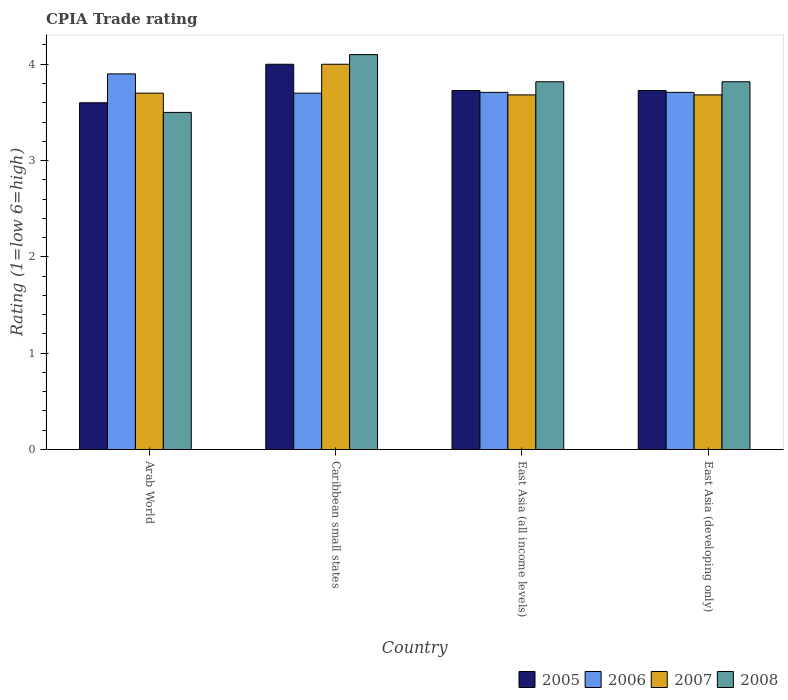How many different coloured bars are there?
Your response must be concise. 4. How many groups of bars are there?
Provide a succinct answer. 4. What is the label of the 1st group of bars from the left?
Keep it short and to the point. Arab World. In how many cases, is the number of bars for a given country not equal to the number of legend labels?
Offer a very short reply. 0. What is the CPIA rating in 2007 in Caribbean small states?
Ensure brevity in your answer.  4. Across all countries, what is the maximum CPIA rating in 2006?
Ensure brevity in your answer.  3.9. Across all countries, what is the minimum CPIA rating in 2006?
Offer a terse response. 3.7. In which country was the CPIA rating in 2007 maximum?
Your answer should be very brief. Caribbean small states. In which country was the CPIA rating in 2005 minimum?
Your answer should be compact. Arab World. What is the total CPIA rating in 2006 in the graph?
Your answer should be very brief. 15.02. What is the difference between the CPIA rating in 2007 in Caribbean small states and that in East Asia (developing only)?
Your answer should be compact. 0.32. What is the difference between the CPIA rating in 2008 in East Asia (all income levels) and the CPIA rating in 2007 in East Asia (developing only)?
Your answer should be very brief. 0.14. What is the average CPIA rating in 2005 per country?
Make the answer very short. 3.76. What is the difference between the CPIA rating of/in 2007 and CPIA rating of/in 2005 in East Asia (developing only)?
Your answer should be compact. -0.05. What is the ratio of the CPIA rating in 2008 in Arab World to that in Caribbean small states?
Provide a succinct answer. 0.85. Is the difference between the CPIA rating in 2007 in East Asia (all income levels) and East Asia (developing only) greater than the difference between the CPIA rating in 2005 in East Asia (all income levels) and East Asia (developing only)?
Make the answer very short. No. What is the difference between the highest and the second highest CPIA rating in 2007?
Keep it short and to the point. -0.02. What is the difference between the highest and the lowest CPIA rating in 2007?
Offer a terse response. 0.32. Is the sum of the CPIA rating in 2005 in East Asia (all income levels) and East Asia (developing only) greater than the maximum CPIA rating in 2006 across all countries?
Offer a terse response. Yes. Is it the case that in every country, the sum of the CPIA rating in 2007 and CPIA rating in 2008 is greater than the sum of CPIA rating in 2005 and CPIA rating in 2006?
Provide a succinct answer. No. What does the 2nd bar from the left in East Asia (all income levels) represents?
Ensure brevity in your answer.  2006. Is it the case that in every country, the sum of the CPIA rating in 2005 and CPIA rating in 2007 is greater than the CPIA rating in 2006?
Offer a very short reply. Yes. How many bars are there?
Provide a short and direct response. 16. How many countries are there in the graph?
Ensure brevity in your answer.  4. What is the difference between two consecutive major ticks on the Y-axis?
Offer a terse response. 1. Are the values on the major ticks of Y-axis written in scientific E-notation?
Your response must be concise. No. How many legend labels are there?
Keep it short and to the point. 4. How are the legend labels stacked?
Provide a succinct answer. Horizontal. What is the title of the graph?
Offer a very short reply. CPIA Trade rating. What is the label or title of the X-axis?
Your answer should be very brief. Country. What is the label or title of the Y-axis?
Ensure brevity in your answer.  Rating (1=low 6=high). What is the Rating (1=low 6=high) of 2007 in Arab World?
Offer a very short reply. 3.7. What is the Rating (1=low 6=high) in 2005 in East Asia (all income levels)?
Your answer should be very brief. 3.73. What is the Rating (1=low 6=high) in 2006 in East Asia (all income levels)?
Offer a very short reply. 3.71. What is the Rating (1=low 6=high) in 2007 in East Asia (all income levels)?
Your answer should be compact. 3.68. What is the Rating (1=low 6=high) in 2008 in East Asia (all income levels)?
Keep it short and to the point. 3.82. What is the Rating (1=low 6=high) of 2005 in East Asia (developing only)?
Provide a short and direct response. 3.73. What is the Rating (1=low 6=high) in 2006 in East Asia (developing only)?
Keep it short and to the point. 3.71. What is the Rating (1=low 6=high) in 2007 in East Asia (developing only)?
Offer a terse response. 3.68. What is the Rating (1=low 6=high) in 2008 in East Asia (developing only)?
Offer a very short reply. 3.82. Across all countries, what is the maximum Rating (1=low 6=high) of 2005?
Keep it short and to the point. 4. Across all countries, what is the minimum Rating (1=low 6=high) in 2007?
Offer a very short reply. 3.68. Across all countries, what is the minimum Rating (1=low 6=high) of 2008?
Keep it short and to the point. 3.5. What is the total Rating (1=low 6=high) in 2005 in the graph?
Your answer should be very brief. 15.05. What is the total Rating (1=low 6=high) of 2006 in the graph?
Your response must be concise. 15.02. What is the total Rating (1=low 6=high) in 2007 in the graph?
Ensure brevity in your answer.  15.06. What is the total Rating (1=low 6=high) of 2008 in the graph?
Ensure brevity in your answer.  15.24. What is the difference between the Rating (1=low 6=high) in 2008 in Arab World and that in Caribbean small states?
Your response must be concise. -0.6. What is the difference between the Rating (1=low 6=high) in 2005 in Arab World and that in East Asia (all income levels)?
Your answer should be compact. -0.13. What is the difference between the Rating (1=low 6=high) in 2006 in Arab World and that in East Asia (all income levels)?
Provide a succinct answer. 0.19. What is the difference between the Rating (1=low 6=high) in 2007 in Arab World and that in East Asia (all income levels)?
Ensure brevity in your answer.  0.02. What is the difference between the Rating (1=low 6=high) in 2008 in Arab World and that in East Asia (all income levels)?
Give a very brief answer. -0.32. What is the difference between the Rating (1=low 6=high) of 2005 in Arab World and that in East Asia (developing only)?
Provide a succinct answer. -0.13. What is the difference between the Rating (1=low 6=high) of 2006 in Arab World and that in East Asia (developing only)?
Your answer should be very brief. 0.19. What is the difference between the Rating (1=low 6=high) of 2007 in Arab World and that in East Asia (developing only)?
Your response must be concise. 0.02. What is the difference between the Rating (1=low 6=high) in 2008 in Arab World and that in East Asia (developing only)?
Offer a terse response. -0.32. What is the difference between the Rating (1=low 6=high) of 2005 in Caribbean small states and that in East Asia (all income levels)?
Your response must be concise. 0.27. What is the difference between the Rating (1=low 6=high) in 2006 in Caribbean small states and that in East Asia (all income levels)?
Your answer should be very brief. -0.01. What is the difference between the Rating (1=low 6=high) in 2007 in Caribbean small states and that in East Asia (all income levels)?
Offer a terse response. 0.32. What is the difference between the Rating (1=low 6=high) in 2008 in Caribbean small states and that in East Asia (all income levels)?
Give a very brief answer. 0.28. What is the difference between the Rating (1=low 6=high) in 2005 in Caribbean small states and that in East Asia (developing only)?
Offer a terse response. 0.27. What is the difference between the Rating (1=low 6=high) of 2006 in Caribbean small states and that in East Asia (developing only)?
Keep it short and to the point. -0.01. What is the difference between the Rating (1=low 6=high) in 2007 in Caribbean small states and that in East Asia (developing only)?
Your answer should be very brief. 0.32. What is the difference between the Rating (1=low 6=high) of 2008 in Caribbean small states and that in East Asia (developing only)?
Offer a terse response. 0.28. What is the difference between the Rating (1=low 6=high) in 2005 in East Asia (all income levels) and that in East Asia (developing only)?
Give a very brief answer. 0. What is the difference between the Rating (1=low 6=high) of 2006 in East Asia (all income levels) and that in East Asia (developing only)?
Make the answer very short. 0. What is the difference between the Rating (1=low 6=high) of 2005 in Arab World and the Rating (1=low 6=high) of 2007 in Caribbean small states?
Keep it short and to the point. -0.4. What is the difference between the Rating (1=low 6=high) in 2005 in Arab World and the Rating (1=low 6=high) in 2008 in Caribbean small states?
Make the answer very short. -0.5. What is the difference between the Rating (1=low 6=high) of 2006 in Arab World and the Rating (1=low 6=high) of 2007 in Caribbean small states?
Provide a succinct answer. -0.1. What is the difference between the Rating (1=low 6=high) of 2006 in Arab World and the Rating (1=low 6=high) of 2008 in Caribbean small states?
Give a very brief answer. -0.2. What is the difference between the Rating (1=low 6=high) of 2005 in Arab World and the Rating (1=low 6=high) of 2006 in East Asia (all income levels)?
Keep it short and to the point. -0.11. What is the difference between the Rating (1=low 6=high) in 2005 in Arab World and the Rating (1=low 6=high) in 2007 in East Asia (all income levels)?
Provide a short and direct response. -0.08. What is the difference between the Rating (1=low 6=high) in 2005 in Arab World and the Rating (1=low 6=high) in 2008 in East Asia (all income levels)?
Ensure brevity in your answer.  -0.22. What is the difference between the Rating (1=low 6=high) in 2006 in Arab World and the Rating (1=low 6=high) in 2007 in East Asia (all income levels)?
Give a very brief answer. 0.22. What is the difference between the Rating (1=low 6=high) of 2006 in Arab World and the Rating (1=low 6=high) of 2008 in East Asia (all income levels)?
Provide a short and direct response. 0.08. What is the difference between the Rating (1=low 6=high) of 2007 in Arab World and the Rating (1=low 6=high) of 2008 in East Asia (all income levels)?
Ensure brevity in your answer.  -0.12. What is the difference between the Rating (1=low 6=high) in 2005 in Arab World and the Rating (1=low 6=high) in 2006 in East Asia (developing only)?
Your response must be concise. -0.11. What is the difference between the Rating (1=low 6=high) of 2005 in Arab World and the Rating (1=low 6=high) of 2007 in East Asia (developing only)?
Give a very brief answer. -0.08. What is the difference between the Rating (1=low 6=high) in 2005 in Arab World and the Rating (1=low 6=high) in 2008 in East Asia (developing only)?
Your response must be concise. -0.22. What is the difference between the Rating (1=low 6=high) of 2006 in Arab World and the Rating (1=low 6=high) of 2007 in East Asia (developing only)?
Provide a short and direct response. 0.22. What is the difference between the Rating (1=low 6=high) of 2006 in Arab World and the Rating (1=low 6=high) of 2008 in East Asia (developing only)?
Make the answer very short. 0.08. What is the difference between the Rating (1=low 6=high) of 2007 in Arab World and the Rating (1=low 6=high) of 2008 in East Asia (developing only)?
Provide a short and direct response. -0.12. What is the difference between the Rating (1=low 6=high) of 2005 in Caribbean small states and the Rating (1=low 6=high) of 2006 in East Asia (all income levels)?
Your answer should be very brief. 0.29. What is the difference between the Rating (1=low 6=high) of 2005 in Caribbean small states and the Rating (1=low 6=high) of 2007 in East Asia (all income levels)?
Give a very brief answer. 0.32. What is the difference between the Rating (1=low 6=high) of 2005 in Caribbean small states and the Rating (1=low 6=high) of 2008 in East Asia (all income levels)?
Your answer should be compact. 0.18. What is the difference between the Rating (1=low 6=high) of 2006 in Caribbean small states and the Rating (1=low 6=high) of 2007 in East Asia (all income levels)?
Provide a short and direct response. 0.02. What is the difference between the Rating (1=low 6=high) of 2006 in Caribbean small states and the Rating (1=low 6=high) of 2008 in East Asia (all income levels)?
Ensure brevity in your answer.  -0.12. What is the difference between the Rating (1=low 6=high) of 2007 in Caribbean small states and the Rating (1=low 6=high) of 2008 in East Asia (all income levels)?
Your answer should be compact. 0.18. What is the difference between the Rating (1=low 6=high) in 2005 in Caribbean small states and the Rating (1=low 6=high) in 2006 in East Asia (developing only)?
Offer a very short reply. 0.29. What is the difference between the Rating (1=low 6=high) of 2005 in Caribbean small states and the Rating (1=low 6=high) of 2007 in East Asia (developing only)?
Keep it short and to the point. 0.32. What is the difference between the Rating (1=low 6=high) in 2005 in Caribbean small states and the Rating (1=low 6=high) in 2008 in East Asia (developing only)?
Give a very brief answer. 0.18. What is the difference between the Rating (1=low 6=high) in 2006 in Caribbean small states and the Rating (1=low 6=high) in 2007 in East Asia (developing only)?
Provide a short and direct response. 0.02. What is the difference between the Rating (1=low 6=high) in 2006 in Caribbean small states and the Rating (1=low 6=high) in 2008 in East Asia (developing only)?
Make the answer very short. -0.12. What is the difference between the Rating (1=low 6=high) in 2007 in Caribbean small states and the Rating (1=low 6=high) in 2008 in East Asia (developing only)?
Offer a very short reply. 0.18. What is the difference between the Rating (1=low 6=high) of 2005 in East Asia (all income levels) and the Rating (1=low 6=high) of 2006 in East Asia (developing only)?
Your answer should be very brief. 0.02. What is the difference between the Rating (1=low 6=high) of 2005 in East Asia (all income levels) and the Rating (1=low 6=high) of 2007 in East Asia (developing only)?
Provide a succinct answer. 0.05. What is the difference between the Rating (1=low 6=high) of 2005 in East Asia (all income levels) and the Rating (1=low 6=high) of 2008 in East Asia (developing only)?
Make the answer very short. -0.09. What is the difference between the Rating (1=low 6=high) of 2006 in East Asia (all income levels) and the Rating (1=low 6=high) of 2007 in East Asia (developing only)?
Provide a short and direct response. 0.03. What is the difference between the Rating (1=low 6=high) in 2006 in East Asia (all income levels) and the Rating (1=low 6=high) in 2008 in East Asia (developing only)?
Provide a short and direct response. -0.11. What is the difference between the Rating (1=low 6=high) in 2007 in East Asia (all income levels) and the Rating (1=low 6=high) in 2008 in East Asia (developing only)?
Give a very brief answer. -0.14. What is the average Rating (1=low 6=high) of 2005 per country?
Keep it short and to the point. 3.76. What is the average Rating (1=low 6=high) of 2006 per country?
Your answer should be very brief. 3.75. What is the average Rating (1=low 6=high) of 2007 per country?
Provide a short and direct response. 3.77. What is the average Rating (1=low 6=high) in 2008 per country?
Provide a short and direct response. 3.81. What is the difference between the Rating (1=low 6=high) of 2005 and Rating (1=low 6=high) of 2007 in Arab World?
Your answer should be compact. -0.1. What is the difference between the Rating (1=low 6=high) in 2005 and Rating (1=low 6=high) in 2008 in Arab World?
Provide a succinct answer. 0.1. What is the difference between the Rating (1=low 6=high) of 2006 and Rating (1=low 6=high) of 2008 in Arab World?
Provide a succinct answer. 0.4. What is the difference between the Rating (1=low 6=high) in 2005 and Rating (1=low 6=high) in 2007 in Caribbean small states?
Provide a succinct answer. 0. What is the difference between the Rating (1=low 6=high) in 2006 and Rating (1=low 6=high) in 2008 in Caribbean small states?
Give a very brief answer. -0.4. What is the difference between the Rating (1=low 6=high) in 2005 and Rating (1=low 6=high) in 2006 in East Asia (all income levels)?
Offer a very short reply. 0.02. What is the difference between the Rating (1=low 6=high) in 2005 and Rating (1=low 6=high) in 2007 in East Asia (all income levels)?
Offer a terse response. 0.05. What is the difference between the Rating (1=low 6=high) of 2005 and Rating (1=low 6=high) of 2008 in East Asia (all income levels)?
Ensure brevity in your answer.  -0.09. What is the difference between the Rating (1=low 6=high) in 2006 and Rating (1=low 6=high) in 2007 in East Asia (all income levels)?
Ensure brevity in your answer.  0.03. What is the difference between the Rating (1=low 6=high) of 2006 and Rating (1=low 6=high) of 2008 in East Asia (all income levels)?
Provide a short and direct response. -0.11. What is the difference between the Rating (1=low 6=high) of 2007 and Rating (1=low 6=high) of 2008 in East Asia (all income levels)?
Give a very brief answer. -0.14. What is the difference between the Rating (1=low 6=high) in 2005 and Rating (1=low 6=high) in 2006 in East Asia (developing only)?
Offer a terse response. 0.02. What is the difference between the Rating (1=low 6=high) in 2005 and Rating (1=low 6=high) in 2007 in East Asia (developing only)?
Keep it short and to the point. 0.05. What is the difference between the Rating (1=low 6=high) of 2005 and Rating (1=low 6=high) of 2008 in East Asia (developing only)?
Your answer should be compact. -0.09. What is the difference between the Rating (1=low 6=high) in 2006 and Rating (1=low 6=high) in 2007 in East Asia (developing only)?
Provide a short and direct response. 0.03. What is the difference between the Rating (1=low 6=high) in 2006 and Rating (1=low 6=high) in 2008 in East Asia (developing only)?
Give a very brief answer. -0.11. What is the difference between the Rating (1=low 6=high) in 2007 and Rating (1=low 6=high) in 2008 in East Asia (developing only)?
Your answer should be compact. -0.14. What is the ratio of the Rating (1=low 6=high) of 2006 in Arab World to that in Caribbean small states?
Offer a very short reply. 1.05. What is the ratio of the Rating (1=low 6=high) in 2007 in Arab World to that in Caribbean small states?
Your answer should be very brief. 0.93. What is the ratio of the Rating (1=low 6=high) of 2008 in Arab World to that in Caribbean small states?
Offer a terse response. 0.85. What is the ratio of the Rating (1=low 6=high) of 2005 in Arab World to that in East Asia (all income levels)?
Ensure brevity in your answer.  0.97. What is the ratio of the Rating (1=low 6=high) of 2006 in Arab World to that in East Asia (all income levels)?
Keep it short and to the point. 1.05. What is the ratio of the Rating (1=low 6=high) in 2007 in Arab World to that in East Asia (all income levels)?
Your response must be concise. 1. What is the ratio of the Rating (1=low 6=high) in 2005 in Arab World to that in East Asia (developing only)?
Keep it short and to the point. 0.97. What is the ratio of the Rating (1=low 6=high) in 2006 in Arab World to that in East Asia (developing only)?
Your response must be concise. 1.05. What is the ratio of the Rating (1=low 6=high) of 2007 in Arab World to that in East Asia (developing only)?
Your answer should be compact. 1. What is the ratio of the Rating (1=low 6=high) in 2008 in Arab World to that in East Asia (developing only)?
Make the answer very short. 0.92. What is the ratio of the Rating (1=low 6=high) in 2005 in Caribbean small states to that in East Asia (all income levels)?
Provide a succinct answer. 1.07. What is the ratio of the Rating (1=low 6=high) in 2006 in Caribbean small states to that in East Asia (all income levels)?
Offer a terse response. 1. What is the ratio of the Rating (1=low 6=high) of 2007 in Caribbean small states to that in East Asia (all income levels)?
Your response must be concise. 1.09. What is the ratio of the Rating (1=low 6=high) of 2008 in Caribbean small states to that in East Asia (all income levels)?
Provide a short and direct response. 1.07. What is the ratio of the Rating (1=low 6=high) in 2005 in Caribbean small states to that in East Asia (developing only)?
Give a very brief answer. 1.07. What is the ratio of the Rating (1=low 6=high) in 2007 in Caribbean small states to that in East Asia (developing only)?
Provide a succinct answer. 1.09. What is the ratio of the Rating (1=low 6=high) of 2008 in Caribbean small states to that in East Asia (developing only)?
Give a very brief answer. 1.07. What is the difference between the highest and the second highest Rating (1=low 6=high) in 2005?
Offer a terse response. 0.27. What is the difference between the highest and the second highest Rating (1=low 6=high) of 2006?
Your answer should be very brief. 0.19. What is the difference between the highest and the second highest Rating (1=low 6=high) of 2008?
Your response must be concise. 0.28. What is the difference between the highest and the lowest Rating (1=low 6=high) in 2006?
Offer a very short reply. 0.2. What is the difference between the highest and the lowest Rating (1=low 6=high) of 2007?
Make the answer very short. 0.32. What is the difference between the highest and the lowest Rating (1=low 6=high) in 2008?
Give a very brief answer. 0.6. 